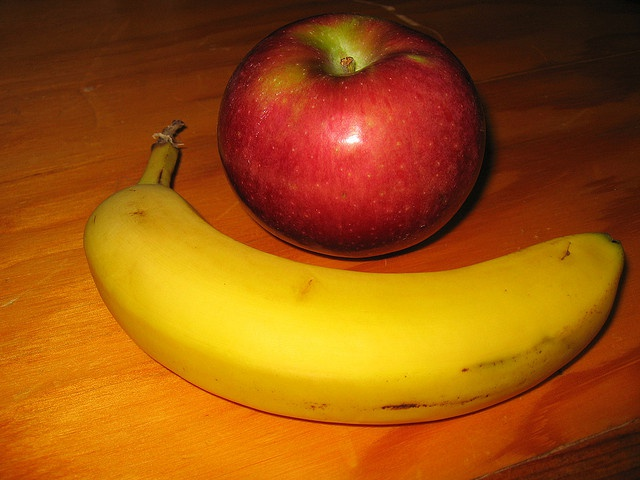Describe the objects in this image and their specific colors. I can see banana in black, orange, gold, and olive tones and apple in black, maroon, and brown tones in this image. 